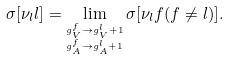Convert formula to latex. <formula><loc_0><loc_0><loc_500><loc_500>\sigma [ \nu _ { l } l ] = \lim _ { \stackrel { g _ { V } ^ { f } \to g _ { V } ^ { l } + 1 } { _ { g _ { A } ^ { f } \to g _ { A } ^ { l } + 1 } } } \sigma [ \nu _ { l } f ( f \neq l ) ] .</formula> 